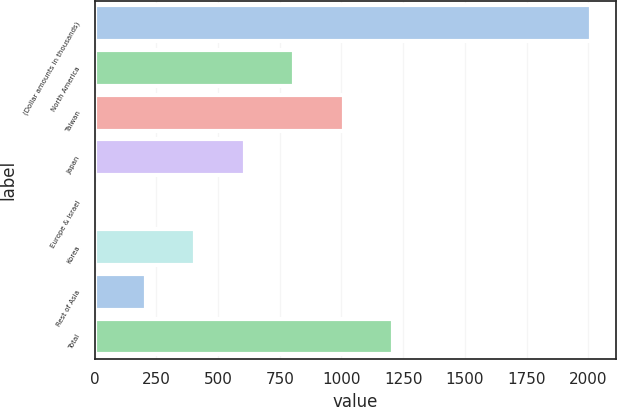Convert chart. <chart><loc_0><loc_0><loc_500><loc_500><bar_chart><fcel>(Dollar amounts in thousands)<fcel>North America<fcel>Taiwan<fcel>Japan<fcel>Europe & Israel<fcel>Korea<fcel>Rest of Asia<fcel>Total<nl><fcel>2013<fcel>809.4<fcel>1010<fcel>608.8<fcel>7<fcel>408.2<fcel>207.6<fcel>1210.6<nl></chart> 